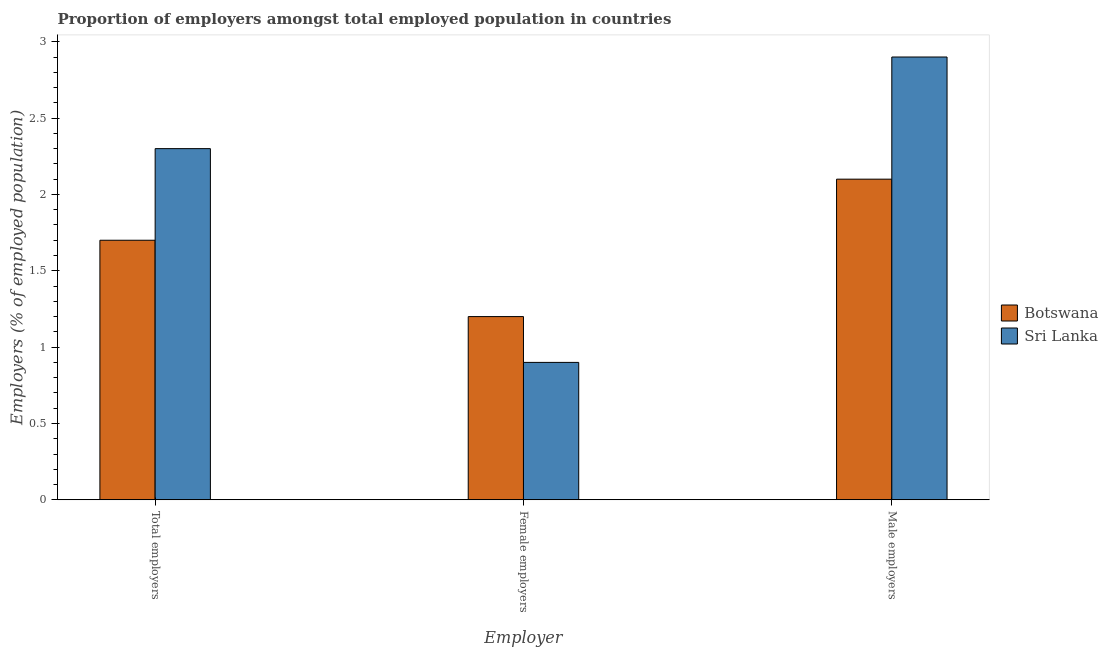How many groups of bars are there?
Your answer should be very brief. 3. Are the number of bars per tick equal to the number of legend labels?
Keep it short and to the point. Yes. Are the number of bars on each tick of the X-axis equal?
Your response must be concise. Yes. What is the label of the 2nd group of bars from the left?
Make the answer very short. Female employers. What is the percentage of female employers in Botswana?
Your response must be concise. 1.2. Across all countries, what is the maximum percentage of male employers?
Keep it short and to the point. 2.9. Across all countries, what is the minimum percentage of male employers?
Offer a terse response. 2.1. In which country was the percentage of total employers maximum?
Ensure brevity in your answer.  Sri Lanka. In which country was the percentage of female employers minimum?
Your answer should be very brief. Sri Lanka. What is the total percentage of female employers in the graph?
Your answer should be very brief. 2.1. What is the difference between the percentage of male employers in Botswana and that in Sri Lanka?
Your answer should be very brief. -0.8. What is the difference between the percentage of female employers in Botswana and the percentage of male employers in Sri Lanka?
Your answer should be compact. -1.7. What is the average percentage of male employers per country?
Your answer should be compact. 2.5. What is the difference between the percentage of total employers and percentage of female employers in Botswana?
Provide a succinct answer. 0.5. What is the ratio of the percentage of female employers in Sri Lanka to that in Botswana?
Ensure brevity in your answer.  0.75. What is the difference between the highest and the second highest percentage of total employers?
Keep it short and to the point. 0.6. What is the difference between the highest and the lowest percentage of female employers?
Provide a succinct answer. 0.3. What does the 2nd bar from the left in Female employers represents?
Ensure brevity in your answer.  Sri Lanka. What does the 1st bar from the right in Total employers represents?
Your answer should be very brief. Sri Lanka. Is it the case that in every country, the sum of the percentage of total employers and percentage of female employers is greater than the percentage of male employers?
Provide a short and direct response. Yes. How many countries are there in the graph?
Your answer should be compact. 2. What is the difference between two consecutive major ticks on the Y-axis?
Offer a very short reply. 0.5. Are the values on the major ticks of Y-axis written in scientific E-notation?
Your response must be concise. No. Does the graph contain grids?
Your response must be concise. No. How are the legend labels stacked?
Offer a very short reply. Vertical. What is the title of the graph?
Provide a short and direct response. Proportion of employers amongst total employed population in countries. Does "Nepal" appear as one of the legend labels in the graph?
Your response must be concise. No. What is the label or title of the X-axis?
Give a very brief answer. Employer. What is the label or title of the Y-axis?
Your answer should be compact. Employers (% of employed population). What is the Employers (% of employed population) in Botswana in Total employers?
Your answer should be compact. 1.7. What is the Employers (% of employed population) of Sri Lanka in Total employers?
Provide a short and direct response. 2.3. What is the Employers (% of employed population) of Botswana in Female employers?
Provide a succinct answer. 1.2. What is the Employers (% of employed population) of Sri Lanka in Female employers?
Provide a short and direct response. 0.9. What is the Employers (% of employed population) in Botswana in Male employers?
Offer a very short reply. 2.1. What is the Employers (% of employed population) of Sri Lanka in Male employers?
Ensure brevity in your answer.  2.9. Across all Employer, what is the maximum Employers (% of employed population) of Botswana?
Provide a succinct answer. 2.1. Across all Employer, what is the maximum Employers (% of employed population) of Sri Lanka?
Make the answer very short. 2.9. Across all Employer, what is the minimum Employers (% of employed population) of Botswana?
Make the answer very short. 1.2. Across all Employer, what is the minimum Employers (% of employed population) of Sri Lanka?
Offer a terse response. 0.9. What is the total Employers (% of employed population) of Botswana in the graph?
Provide a succinct answer. 5. What is the difference between the Employers (% of employed population) of Botswana in Total employers and that in Female employers?
Give a very brief answer. 0.5. What is the difference between the Employers (% of employed population) in Sri Lanka in Total employers and that in Female employers?
Your response must be concise. 1.4. What is the difference between the Employers (% of employed population) of Sri Lanka in Total employers and that in Male employers?
Ensure brevity in your answer.  -0.6. What is the difference between the Employers (% of employed population) in Sri Lanka in Female employers and that in Male employers?
Your response must be concise. -2. What is the difference between the Employers (% of employed population) of Botswana in Total employers and the Employers (% of employed population) of Sri Lanka in Male employers?
Ensure brevity in your answer.  -1.2. What is the difference between the Employers (% of employed population) of Botswana in Female employers and the Employers (% of employed population) of Sri Lanka in Male employers?
Provide a succinct answer. -1.7. What is the average Employers (% of employed population) in Botswana per Employer?
Make the answer very short. 1.67. What is the average Employers (% of employed population) in Sri Lanka per Employer?
Your answer should be very brief. 2.03. What is the difference between the Employers (% of employed population) of Botswana and Employers (% of employed population) of Sri Lanka in Total employers?
Offer a terse response. -0.6. What is the difference between the Employers (% of employed population) in Botswana and Employers (% of employed population) in Sri Lanka in Female employers?
Your answer should be very brief. 0.3. What is the ratio of the Employers (% of employed population) in Botswana in Total employers to that in Female employers?
Your answer should be very brief. 1.42. What is the ratio of the Employers (% of employed population) of Sri Lanka in Total employers to that in Female employers?
Make the answer very short. 2.56. What is the ratio of the Employers (% of employed population) in Botswana in Total employers to that in Male employers?
Your answer should be compact. 0.81. What is the ratio of the Employers (% of employed population) in Sri Lanka in Total employers to that in Male employers?
Your answer should be very brief. 0.79. What is the ratio of the Employers (% of employed population) of Sri Lanka in Female employers to that in Male employers?
Your response must be concise. 0.31. What is the difference between the highest and the second highest Employers (% of employed population) of Botswana?
Your answer should be very brief. 0.4. What is the difference between the highest and the second highest Employers (% of employed population) in Sri Lanka?
Make the answer very short. 0.6. 